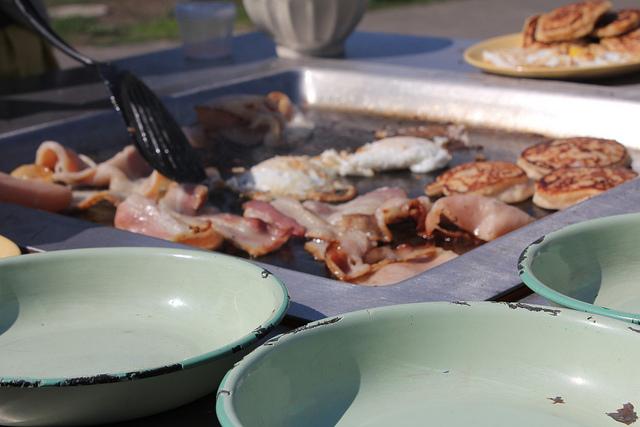What kind of meat is cooking?
Answer briefly. Bacon. Are the plates old?
Short answer required. Yes. They appear old?
Quick response, please. Yes. 